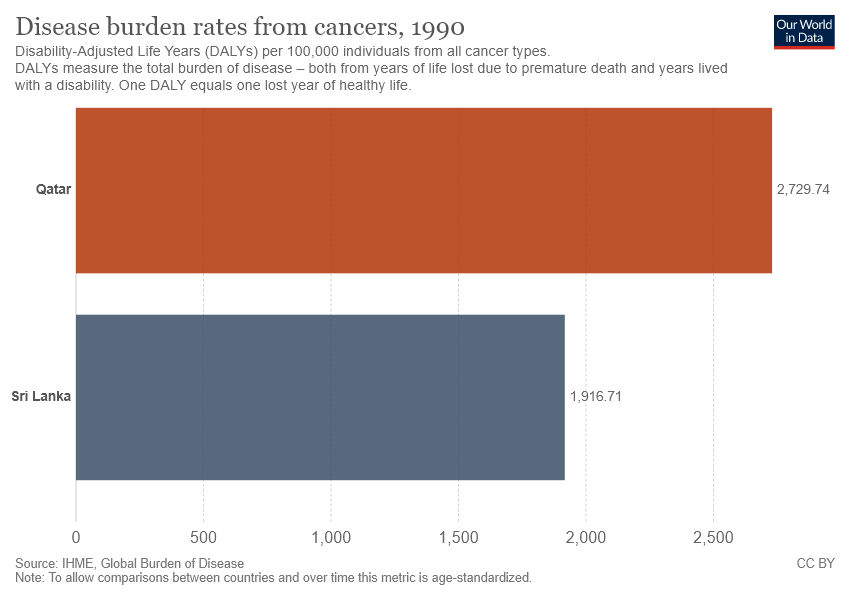Outline some significant characteristics in this image. The sum of the disease burden rate from cancer in both countries is 4646.45. The burden of cancer disease in Qatar is 2,729.74 cases per 100,000 population. 